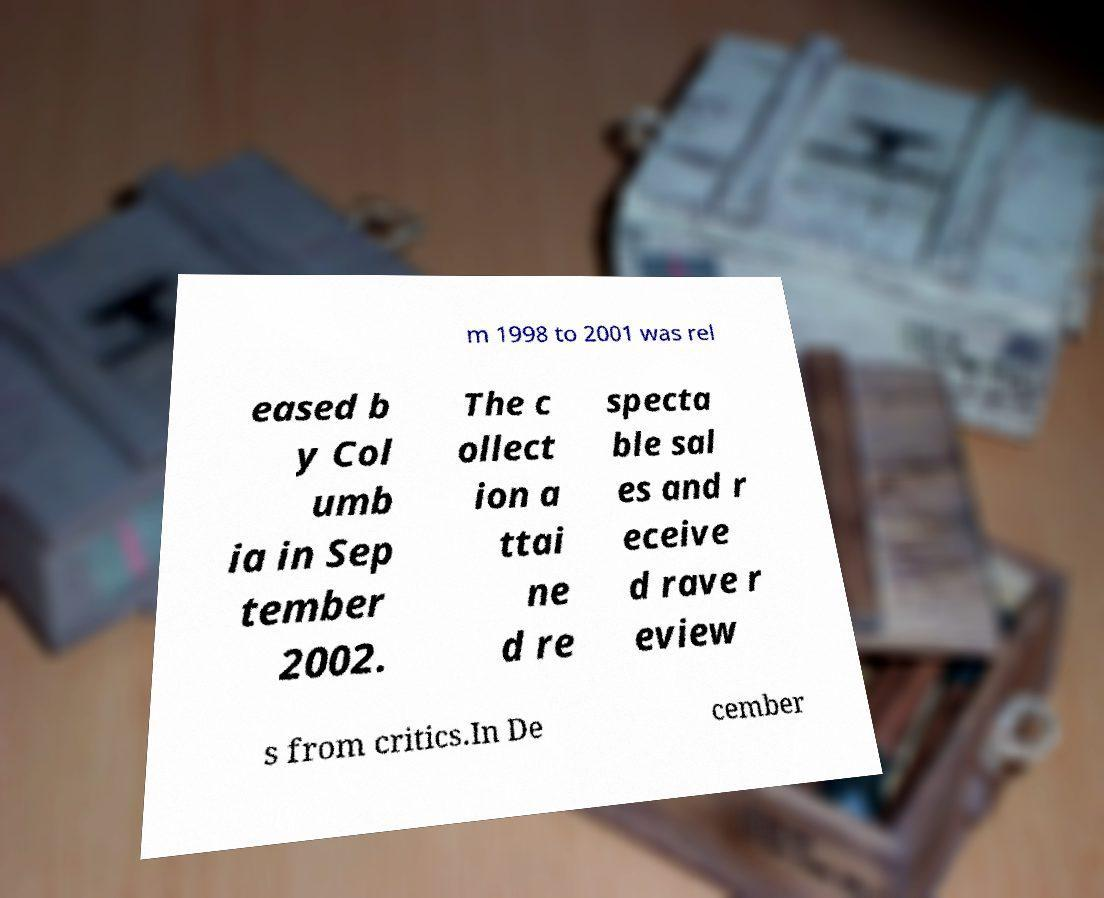Please identify and transcribe the text found in this image. m 1998 to 2001 was rel eased b y Col umb ia in Sep tember 2002. The c ollect ion a ttai ne d re specta ble sal es and r eceive d rave r eview s from critics.In De cember 